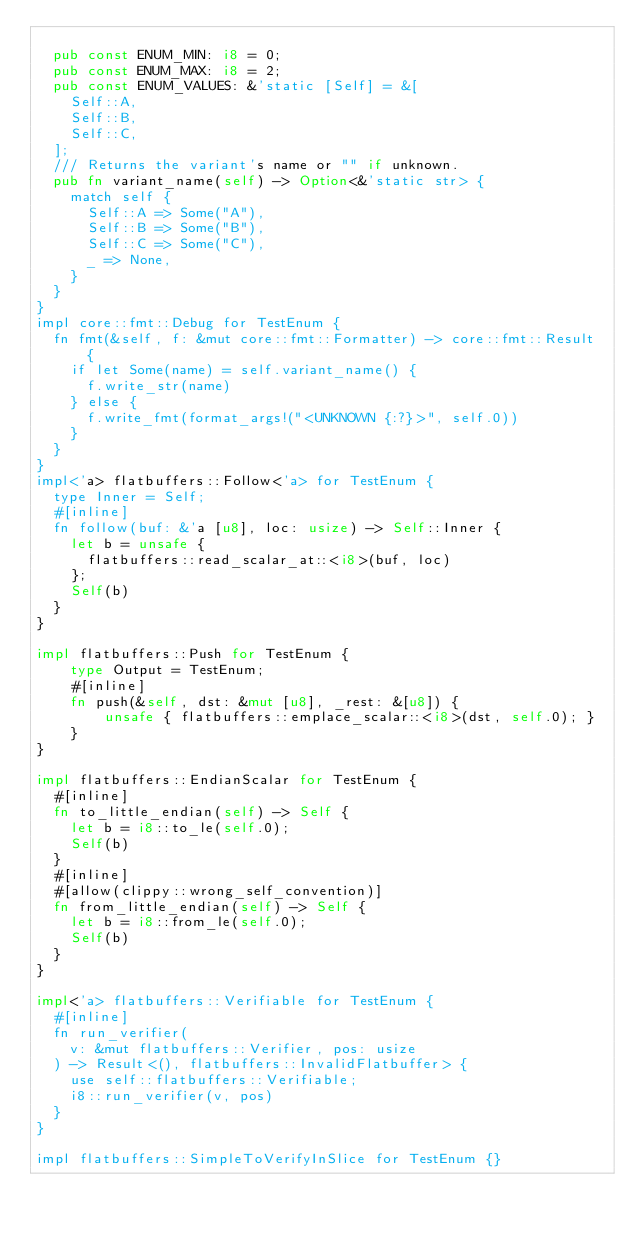<code> <loc_0><loc_0><loc_500><loc_500><_Rust_>
  pub const ENUM_MIN: i8 = 0;
  pub const ENUM_MAX: i8 = 2;
  pub const ENUM_VALUES: &'static [Self] = &[
    Self::A,
    Self::B,
    Self::C,
  ];
  /// Returns the variant's name or "" if unknown.
  pub fn variant_name(self) -> Option<&'static str> {
    match self {
      Self::A => Some("A"),
      Self::B => Some("B"),
      Self::C => Some("C"),
      _ => None,
    }
  }
}
impl core::fmt::Debug for TestEnum {
  fn fmt(&self, f: &mut core::fmt::Formatter) -> core::fmt::Result {
    if let Some(name) = self.variant_name() {
      f.write_str(name)
    } else {
      f.write_fmt(format_args!("<UNKNOWN {:?}>", self.0))
    }
  }
}
impl<'a> flatbuffers::Follow<'a> for TestEnum {
  type Inner = Self;
  #[inline]
  fn follow(buf: &'a [u8], loc: usize) -> Self::Inner {
    let b = unsafe {
      flatbuffers::read_scalar_at::<i8>(buf, loc)
    };
    Self(b)
  }
}

impl flatbuffers::Push for TestEnum {
    type Output = TestEnum;
    #[inline]
    fn push(&self, dst: &mut [u8], _rest: &[u8]) {
        unsafe { flatbuffers::emplace_scalar::<i8>(dst, self.0); }
    }
}

impl flatbuffers::EndianScalar for TestEnum {
  #[inline]
  fn to_little_endian(self) -> Self {
    let b = i8::to_le(self.0);
    Self(b)
  }
  #[inline]
  #[allow(clippy::wrong_self_convention)]
  fn from_little_endian(self) -> Self {
    let b = i8::from_le(self.0);
    Self(b)
  }
}

impl<'a> flatbuffers::Verifiable for TestEnum {
  #[inline]
  fn run_verifier(
    v: &mut flatbuffers::Verifier, pos: usize
  ) -> Result<(), flatbuffers::InvalidFlatbuffer> {
    use self::flatbuffers::Verifiable;
    i8::run_verifier(v, pos)
  }
}

impl flatbuffers::SimpleToVerifyInSlice for TestEnum {}
</code> 